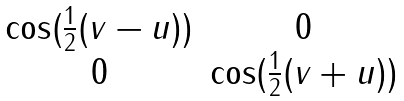<formula> <loc_0><loc_0><loc_500><loc_500>\begin{matrix} \cos ( \frac { 1 } { 2 } ( v - u ) ) & 0 \\ 0 & \cos ( \frac { 1 } { 2 } ( v + u ) ) \end{matrix}</formula> 